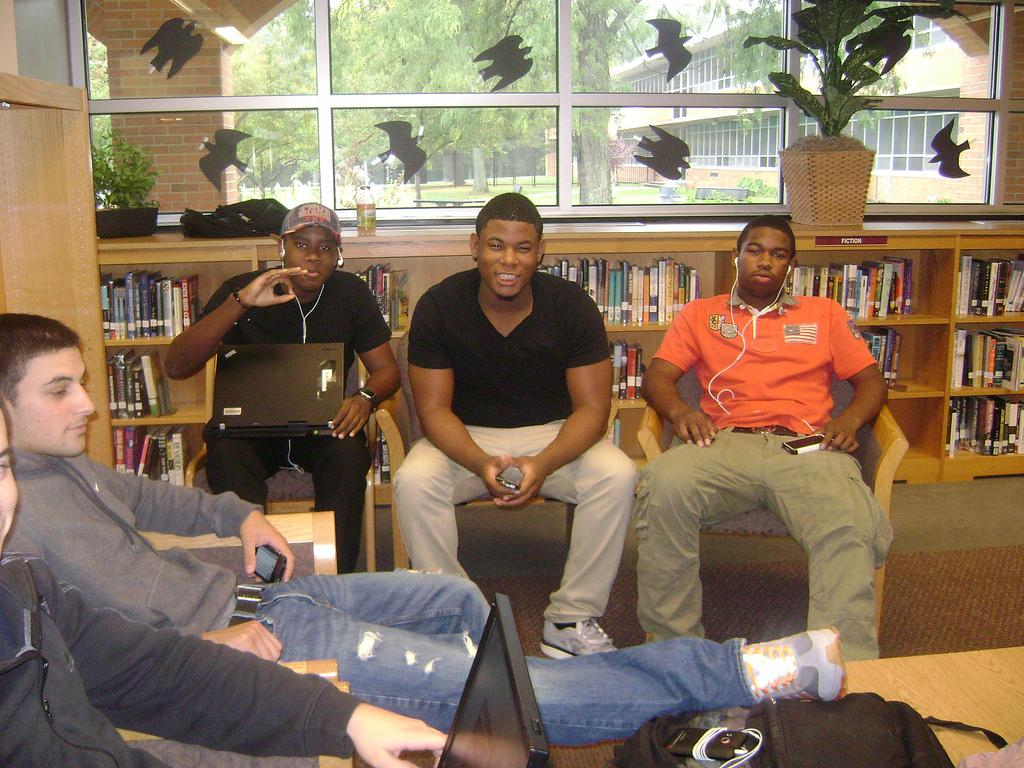Question: how many kids you see?
Choices:
A. 5.
B. 3.
C. 4.
D. 6.
Answer with the letter. Answer: A Question: what kind of earphones are those?
Choices:
A. Headphones.
B. EarPods.
C. Earbuds.
D. Headset.
Answer with the letter. Answer: C Question: who is wearing torn jeans?
Choices:
A. Girl with pink slippers.
B. Man with worn blue sneakers.
C. Woman with black heels.
D. Kid with orange and white shoe.
Answer with the letter. Answer: D Question: how are the windows decorated?
Choices:
A. With black paper bats.
B. With fake snow.
C. With glitter.
D. With angels and shepherds.
Answer with the letter. Answer: A Question: what are the shelves full of?
Choices:
A. Canned goods.
B. Old mason jars.
C. Books.
D. Toys.
Answer with the letter. Answer: C Question: where are the trees?
Choices:
A. On the street.
B. Outside the window.
C. In the yard.
D. Near the neighboring house.
Answer with the letter. Answer: B Question: how many men wear headphones?
Choices:
A. Five.
B. Seven.
C. Two.
D. Half of them.
Answer with the letter. Answer: C Question: what is brown?
Choices:
A. Carpet.
B. Wood floor.
C. Tiles.
D. Chair.
Answer with the letter. Answer: A Question: what has three levels?
Choices:
A. Entertainment concole.
B. Desk.
C. Coffee table.
D. Bookshelves.
Answer with the letter. Answer: D Question: what color is the backpack that the man is resting his foot on?
Choices:
A. Dark green.
B. Red.
C. Navy blue.
D. Black.
Answer with the letter. Answer: D Question: how many people are sitting on chairs?
Choices:
A. Six.
B. Two.
C. Four.
D. Five.
Answer with the letter. Answer: D Question: how many black men are there?
Choices:
A. Three.
B. Two.
C. Four.
D. Five.
Answer with the letter. Answer: A Question: what living this is on the shelves?
Choices:
A. A book.
B. A model car.
C. A potted plant.
D. A tissue box.
Answer with the letter. Answer: C Question: what color shirt is the man on the right wearing?
Choices:
A. Orange.
B. Red.
C. Yellow.
D. Green.
Answer with the letter. Answer: A Question: what are two of the men using?
Choices:
A. Two of the men are using a notebook.
B. Two of the men are using a fishing pole.
C. Two of the men are using a writing instrument.
D. Two of the men are using laptops.
Answer with the letter. Answer: D Question: how many men are sitting around?
Choices:
A. Six.
B. Five men sitting around.
C. Three.
D. One.
Answer with the letter. Answer: B Question: what is the man on the far right wearing?
Choices:
A. The man is wearing earrings.
B. The man is wearing a jacket.
C. The man is wearing an orange shirt and headphones.
D. The man is wearing blue jeans and a white shirt.
Answer with the letter. Answer: C Question: what has rips?
Choices:
A. Jeans.
B. Paper.
C. Heart.
D. Tent.
Answer with the letter. Answer: A 